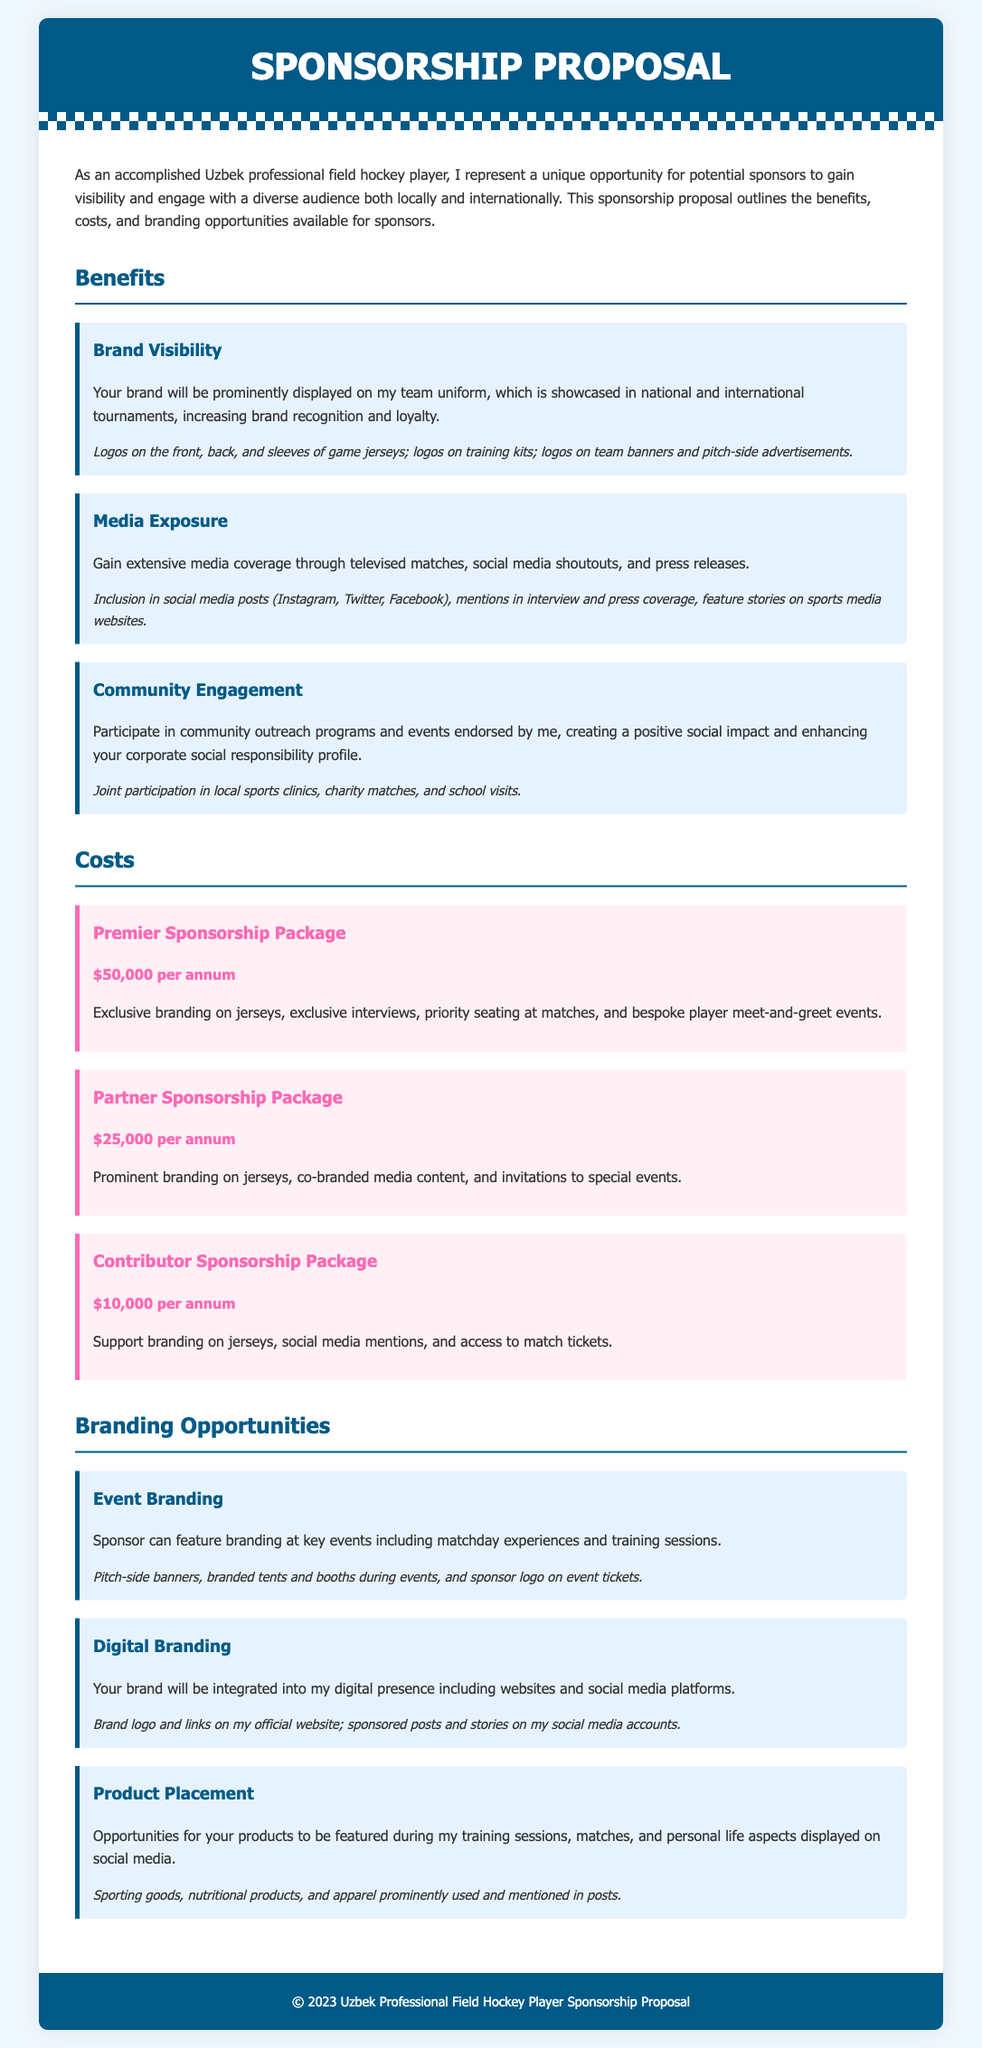What is the sponsorship cost for the Premier Sponsorship Package? The document states the cost for the Premier Sponsorship Package is listed under the Costs section, specifically mentioned as an annual fee.
Answer: $50,000 per annum What type of exposure does Media Exposure provide? The document describes Media Exposure benefits in terms of the various platforms that will include coverage and mentions for the sponsor.
Answer: Extensive media coverage What are the advantages of the Community Engagement benefit? The document outlines how sponsors can participate in community events and the positive social impact it creates.
Answer: Positive social impact What is included in the Contributor Sponsorship Package? The details under the Costs section mention specific offerings related to this sponsorship tier.
Answer: Support branding on jerseys, social media mentions, and access to match tickets What branding opportunities are available in the Digital Branding section? The document lists how sponsors can integrate their brand into the player's digital presence in various ways.
Answer: Sponsored posts and stories on social media Which benefit involves participation in local sports clinics? The document specifies the Community Engagement benefit, mentioning this specific type of event as part of the offerings.
Answer: Community Engagement How many sponsorship packages are listed in the document? By counting the unique sponsorship packages outlined in the Costs section, the total can be identified.
Answer: Three What kind of branding is featured at key events? The document mentions Event Branding as an opportunity, specifying how sponsors can showcase their brand at these occasions.
Answer: Branding at key events What color is used for headings in the Benefits section? The visual style of the document provides specific colors for headings, which is evident in the respective section.
Answer: #005a87 